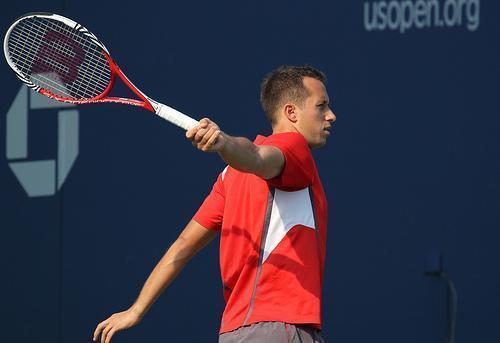How many rackets?
Give a very brief answer. 1. 